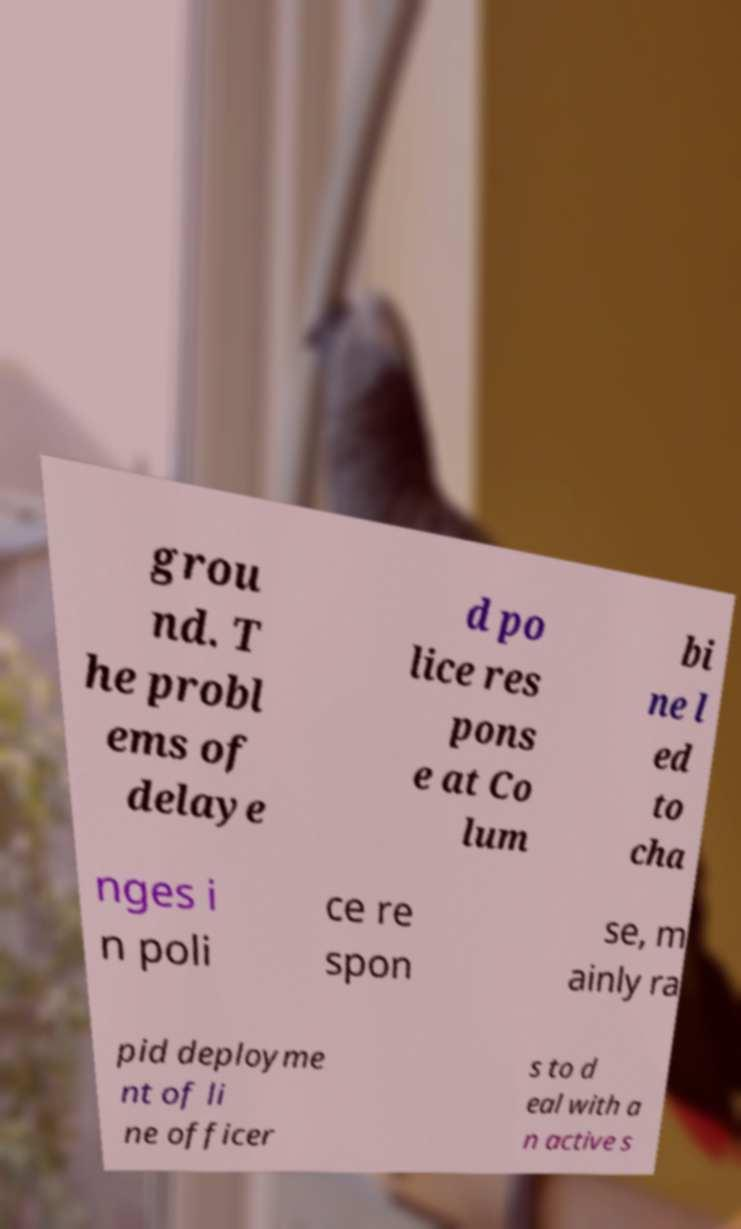For documentation purposes, I need the text within this image transcribed. Could you provide that? grou nd. T he probl ems of delaye d po lice res pons e at Co lum bi ne l ed to cha nges i n poli ce re spon se, m ainly ra pid deployme nt of li ne officer s to d eal with a n active s 